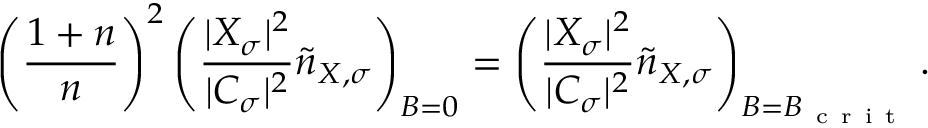Convert formula to latex. <formula><loc_0><loc_0><loc_500><loc_500>\left ( \frac { 1 + n } { n } \right ) ^ { 2 } \left ( \frac { | X _ { \sigma } | ^ { 2 } } { | C _ { \sigma } | ^ { 2 } } \tilde { n } _ { X , \sigma } \right ) _ { B = 0 } = \left ( \frac { | X _ { \sigma } | ^ { 2 } } { | C _ { \sigma } | ^ { 2 } } \tilde { n } _ { X , \sigma } \right ) _ { B = B _ { c r i t } } .</formula> 